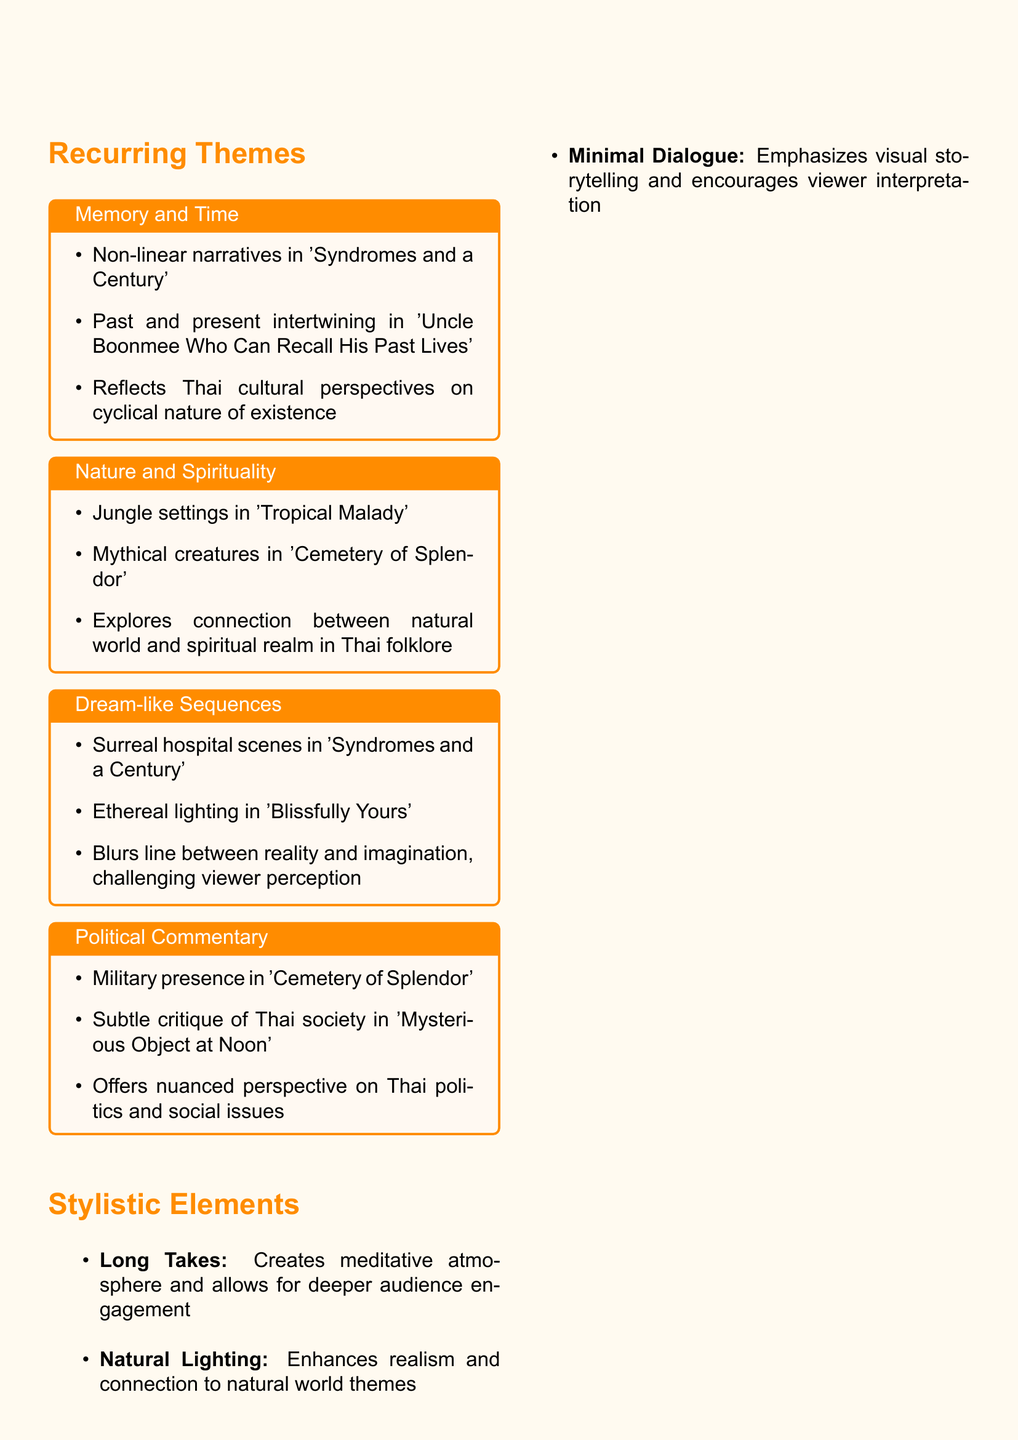what is a significant theme in Apichatpong Weerasethakul's films? The document lists several themes, one of which is "Memory and Time."
Answer: Memory and Time which award did 'Blissfully Yours' win? The document states that 'Blissfully Yours' won the Un Certain Regard award at Cannes.
Answer: Un Certain Regard what year did Apichatpong Weerasethakul release 'Thirdworld'? The document mentions that 'Thirdworld' was released in 1998 as part of his early work.
Answer: 1998 what is a notable stylistic element used in his films? The document highlights "Long Takes" as a notable stylistic element.
Answer: Long Takes how does the theme of Nature and Spirituality manifest in his films? The document provides examples, such as jungle settings in 'Tropical Malady' and mythical creatures in 'Cemetery of Splendor'.
Answer: Jungle settings and mythical creatures which film won the Palme d'Or? According to the document, 'Uncle Boonmee Who Can Recall His Past Lives' won the Palme d'Or.
Answer: Uncle Boonmee Who Can Recall His Past Lives what is a challenge some viewers face with his films? The document reveals that some viewers find his work slow-paced and abstract.
Answer: Slow-paced and abstract what recent project did Apichatpong Weerasethakul undertake? The document states that he expanded into installation art with 'Fever Room' in 2015.
Answer: Fever Room 